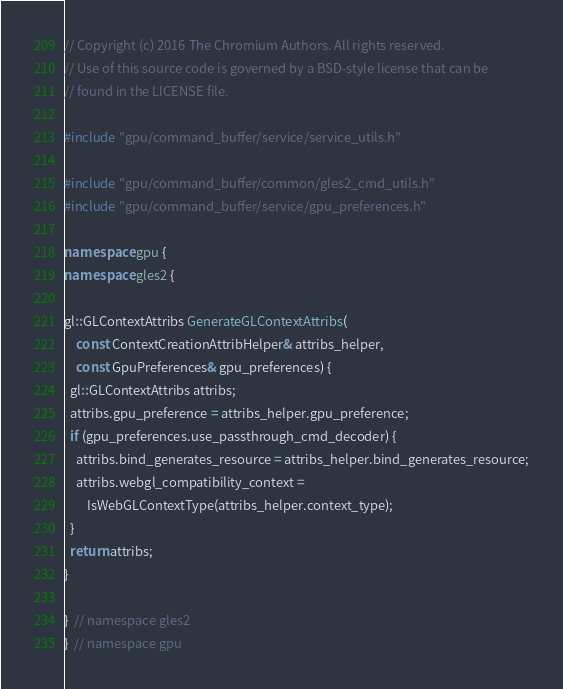<code> <loc_0><loc_0><loc_500><loc_500><_C++_>// Copyright (c) 2016 The Chromium Authors. All rights reserved.
// Use of this source code is governed by a BSD-style license that can be
// found in the LICENSE file.

#include "gpu/command_buffer/service/service_utils.h"

#include "gpu/command_buffer/common/gles2_cmd_utils.h"
#include "gpu/command_buffer/service/gpu_preferences.h"

namespace gpu {
namespace gles2 {

gl::GLContextAttribs GenerateGLContextAttribs(
    const ContextCreationAttribHelper& attribs_helper,
    const GpuPreferences& gpu_preferences) {
  gl::GLContextAttribs attribs;
  attribs.gpu_preference = attribs_helper.gpu_preference;
  if (gpu_preferences.use_passthrough_cmd_decoder) {
    attribs.bind_generates_resource = attribs_helper.bind_generates_resource;
    attribs.webgl_compatibility_context =
        IsWebGLContextType(attribs_helper.context_type);
  }
  return attribs;
}

}  // namespace gles2
}  // namespace gpu
</code> 